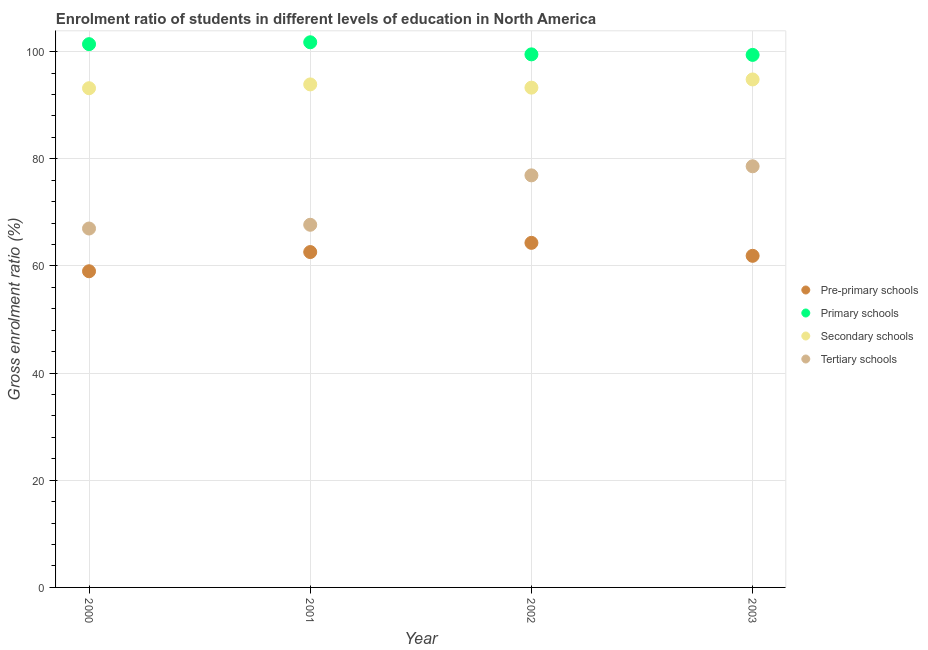How many different coloured dotlines are there?
Provide a succinct answer. 4. Is the number of dotlines equal to the number of legend labels?
Offer a terse response. Yes. What is the gross enrolment ratio in pre-primary schools in 2000?
Offer a terse response. 59.01. Across all years, what is the maximum gross enrolment ratio in primary schools?
Offer a very short reply. 101.74. Across all years, what is the minimum gross enrolment ratio in secondary schools?
Give a very brief answer. 93.17. What is the total gross enrolment ratio in pre-primary schools in the graph?
Keep it short and to the point. 247.8. What is the difference between the gross enrolment ratio in pre-primary schools in 2000 and that in 2003?
Keep it short and to the point. -2.88. What is the difference between the gross enrolment ratio in tertiary schools in 2003 and the gross enrolment ratio in secondary schools in 2002?
Keep it short and to the point. -14.68. What is the average gross enrolment ratio in tertiary schools per year?
Provide a short and direct response. 72.54. In the year 2001, what is the difference between the gross enrolment ratio in pre-primary schools and gross enrolment ratio in primary schools?
Keep it short and to the point. -39.15. In how many years, is the gross enrolment ratio in pre-primary schools greater than 92 %?
Your response must be concise. 0. What is the ratio of the gross enrolment ratio in primary schools in 2000 to that in 2001?
Give a very brief answer. 1. Is the gross enrolment ratio in secondary schools in 2001 less than that in 2003?
Give a very brief answer. Yes. Is the difference between the gross enrolment ratio in pre-primary schools in 2000 and 2003 greater than the difference between the gross enrolment ratio in secondary schools in 2000 and 2003?
Offer a very short reply. No. What is the difference between the highest and the second highest gross enrolment ratio in tertiary schools?
Keep it short and to the point. 1.69. What is the difference between the highest and the lowest gross enrolment ratio in tertiary schools?
Your answer should be compact. 11.61. Is the sum of the gross enrolment ratio in primary schools in 2000 and 2003 greater than the maximum gross enrolment ratio in secondary schools across all years?
Provide a succinct answer. Yes. Is it the case that in every year, the sum of the gross enrolment ratio in secondary schools and gross enrolment ratio in tertiary schools is greater than the sum of gross enrolment ratio in pre-primary schools and gross enrolment ratio in primary schools?
Your answer should be very brief. No. Is it the case that in every year, the sum of the gross enrolment ratio in pre-primary schools and gross enrolment ratio in primary schools is greater than the gross enrolment ratio in secondary schools?
Keep it short and to the point. Yes. Is the gross enrolment ratio in pre-primary schools strictly less than the gross enrolment ratio in secondary schools over the years?
Give a very brief answer. Yes. How many dotlines are there?
Give a very brief answer. 4. How many years are there in the graph?
Your answer should be compact. 4. What is the difference between two consecutive major ticks on the Y-axis?
Provide a succinct answer. 20. Are the values on the major ticks of Y-axis written in scientific E-notation?
Offer a very short reply. No. Does the graph contain any zero values?
Provide a short and direct response. No. Where does the legend appear in the graph?
Keep it short and to the point. Center right. How are the legend labels stacked?
Ensure brevity in your answer.  Vertical. What is the title of the graph?
Provide a short and direct response. Enrolment ratio of students in different levels of education in North America. Does "Quality of logistic services" appear as one of the legend labels in the graph?
Offer a very short reply. No. What is the label or title of the Y-axis?
Keep it short and to the point. Gross enrolment ratio (%). What is the Gross enrolment ratio (%) in Pre-primary schools in 2000?
Your response must be concise. 59.01. What is the Gross enrolment ratio (%) of Primary schools in 2000?
Make the answer very short. 101.39. What is the Gross enrolment ratio (%) in Secondary schools in 2000?
Ensure brevity in your answer.  93.17. What is the Gross enrolment ratio (%) in Tertiary schools in 2000?
Your response must be concise. 66.98. What is the Gross enrolment ratio (%) in Pre-primary schools in 2001?
Offer a terse response. 62.59. What is the Gross enrolment ratio (%) of Primary schools in 2001?
Make the answer very short. 101.74. What is the Gross enrolment ratio (%) in Secondary schools in 2001?
Ensure brevity in your answer.  93.88. What is the Gross enrolment ratio (%) of Tertiary schools in 2001?
Make the answer very short. 67.68. What is the Gross enrolment ratio (%) in Pre-primary schools in 2002?
Keep it short and to the point. 64.31. What is the Gross enrolment ratio (%) of Primary schools in 2002?
Your response must be concise. 99.49. What is the Gross enrolment ratio (%) of Secondary schools in 2002?
Keep it short and to the point. 93.28. What is the Gross enrolment ratio (%) of Tertiary schools in 2002?
Give a very brief answer. 76.91. What is the Gross enrolment ratio (%) in Pre-primary schools in 2003?
Keep it short and to the point. 61.89. What is the Gross enrolment ratio (%) of Primary schools in 2003?
Provide a short and direct response. 99.39. What is the Gross enrolment ratio (%) in Secondary schools in 2003?
Your answer should be very brief. 94.81. What is the Gross enrolment ratio (%) in Tertiary schools in 2003?
Your answer should be very brief. 78.6. Across all years, what is the maximum Gross enrolment ratio (%) of Pre-primary schools?
Make the answer very short. 64.31. Across all years, what is the maximum Gross enrolment ratio (%) in Primary schools?
Keep it short and to the point. 101.74. Across all years, what is the maximum Gross enrolment ratio (%) in Secondary schools?
Your answer should be very brief. 94.81. Across all years, what is the maximum Gross enrolment ratio (%) of Tertiary schools?
Keep it short and to the point. 78.6. Across all years, what is the minimum Gross enrolment ratio (%) of Pre-primary schools?
Ensure brevity in your answer.  59.01. Across all years, what is the minimum Gross enrolment ratio (%) of Primary schools?
Keep it short and to the point. 99.39. Across all years, what is the minimum Gross enrolment ratio (%) of Secondary schools?
Keep it short and to the point. 93.17. Across all years, what is the minimum Gross enrolment ratio (%) in Tertiary schools?
Your answer should be very brief. 66.98. What is the total Gross enrolment ratio (%) of Pre-primary schools in the graph?
Make the answer very short. 247.8. What is the total Gross enrolment ratio (%) in Primary schools in the graph?
Keep it short and to the point. 402.01. What is the total Gross enrolment ratio (%) of Secondary schools in the graph?
Ensure brevity in your answer.  375.13. What is the total Gross enrolment ratio (%) of Tertiary schools in the graph?
Keep it short and to the point. 290.17. What is the difference between the Gross enrolment ratio (%) of Pre-primary schools in 2000 and that in 2001?
Provide a short and direct response. -3.58. What is the difference between the Gross enrolment ratio (%) of Primary schools in 2000 and that in 2001?
Your response must be concise. -0.35. What is the difference between the Gross enrolment ratio (%) in Secondary schools in 2000 and that in 2001?
Give a very brief answer. -0.71. What is the difference between the Gross enrolment ratio (%) of Pre-primary schools in 2000 and that in 2002?
Offer a terse response. -5.3. What is the difference between the Gross enrolment ratio (%) in Primary schools in 2000 and that in 2002?
Keep it short and to the point. 1.9. What is the difference between the Gross enrolment ratio (%) in Secondary schools in 2000 and that in 2002?
Your answer should be compact. -0.11. What is the difference between the Gross enrolment ratio (%) in Tertiary schools in 2000 and that in 2002?
Provide a succinct answer. -9.92. What is the difference between the Gross enrolment ratio (%) in Pre-primary schools in 2000 and that in 2003?
Your answer should be compact. -2.88. What is the difference between the Gross enrolment ratio (%) in Primary schools in 2000 and that in 2003?
Keep it short and to the point. 2. What is the difference between the Gross enrolment ratio (%) in Secondary schools in 2000 and that in 2003?
Your response must be concise. -1.64. What is the difference between the Gross enrolment ratio (%) of Tertiary schools in 2000 and that in 2003?
Your answer should be very brief. -11.61. What is the difference between the Gross enrolment ratio (%) of Pre-primary schools in 2001 and that in 2002?
Provide a short and direct response. -1.72. What is the difference between the Gross enrolment ratio (%) of Primary schools in 2001 and that in 2002?
Keep it short and to the point. 2.26. What is the difference between the Gross enrolment ratio (%) in Secondary schools in 2001 and that in 2002?
Give a very brief answer. 0.6. What is the difference between the Gross enrolment ratio (%) of Tertiary schools in 2001 and that in 2002?
Provide a succinct answer. -9.22. What is the difference between the Gross enrolment ratio (%) of Pre-primary schools in 2001 and that in 2003?
Offer a terse response. 0.7. What is the difference between the Gross enrolment ratio (%) in Primary schools in 2001 and that in 2003?
Keep it short and to the point. 2.36. What is the difference between the Gross enrolment ratio (%) of Secondary schools in 2001 and that in 2003?
Ensure brevity in your answer.  -0.93. What is the difference between the Gross enrolment ratio (%) in Tertiary schools in 2001 and that in 2003?
Keep it short and to the point. -10.91. What is the difference between the Gross enrolment ratio (%) in Pre-primary schools in 2002 and that in 2003?
Offer a terse response. 2.42. What is the difference between the Gross enrolment ratio (%) in Primary schools in 2002 and that in 2003?
Give a very brief answer. 0.1. What is the difference between the Gross enrolment ratio (%) in Secondary schools in 2002 and that in 2003?
Your answer should be compact. -1.53. What is the difference between the Gross enrolment ratio (%) in Tertiary schools in 2002 and that in 2003?
Your answer should be very brief. -1.69. What is the difference between the Gross enrolment ratio (%) of Pre-primary schools in 2000 and the Gross enrolment ratio (%) of Primary schools in 2001?
Ensure brevity in your answer.  -42.74. What is the difference between the Gross enrolment ratio (%) in Pre-primary schools in 2000 and the Gross enrolment ratio (%) in Secondary schools in 2001?
Provide a succinct answer. -34.87. What is the difference between the Gross enrolment ratio (%) of Pre-primary schools in 2000 and the Gross enrolment ratio (%) of Tertiary schools in 2001?
Offer a very short reply. -8.68. What is the difference between the Gross enrolment ratio (%) of Primary schools in 2000 and the Gross enrolment ratio (%) of Secondary schools in 2001?
Your response must be concise. 7.51. What is the difference between the Gross enrolment ratio (%) of Primary schools in 2000 and the Gross enrolment ratio (%) of Tertiary schools in 2001?
Make the answer very short. 33.71. What is the difference between the Gross enrolment ratio (%) in Secondary schools in 2000 and the Gross enrolment ratio (%) in Tertiary schools in 2001?
Your response must be concise. 25.48. What is the difference between the Gross enrolment ratio (%) of Pre-primary schools in 2000 and the Gross enrolment ratio (%) of Primary schools in 2002?
Provide a short and direct response. -40.48. What is the difference between the Gross enrolment ratio (%) of Pre-primary schools in 2000 and the Gross enrolment ratio (%) of Secondary schools in 2002?
Keep it short and to the point. -34.27. What is the difference between the Gross enrolment ratio (%) in Pre-primary schools in 2000 and the Gross enrolment ratio (%) in Tertiary schools in 2002?
Your answer should be compact. -17.9. What is the difference between the Gross enrolment ratio (%) in Primary schools in 2000 and the Gross enrolment ratio (%) in Secondary schools in 2002?
Provide a succinct answer. 8.12. What is the difference between the Gross enrolment ratio (%) of Primary schools in 2000 and the Gross enrolment ratio (%) of Tertiary schools in 2002?
Your answer should be very brief. 24.49. What is the difference between the Gross enrolment ratio (%) of Secondary schools in 2000 and the Gross enrolment ratio (%) of Tertiary schools in 2002?
Provide a short and direct response. 16.26. What is the difference between the Gross enrolment ratio (%) of Pre-primary schools in 2000 and the Gross enrolment ratio (%) of Primary schools in 2003?
Make the answer very short. -40.38. What is the difference between the Gross enrolment ratio (%) in Pre-primary schools in 2000 and the Gross enrolment ratio (%) in Secondary schools in 2003?
Ensure brevity in your answer.  -35.8. What is the difference between the Gross enrolment ratio (%) of Pre-primary schools in 2000 and the Gross enrolment ratio (%) of Tertiary schools in 2003?
Make the answer very short. -19.59. What is the difference between the Gross enrolment ratio (%) of Primary schools in 2000 and the Gross enrolment ratio (%) of Secondary schools in 2003?
Your response must be concise. 6.59. What is the difference between the Gross enrolment ratio (%) in Primary schools in 2000 and the Gross enrolment ratio (%) in Tertiary schools in 2003?
Give a very brief answer. 22.79. What is the difference between the Gross enrolment ratio (%) of Secondary schools in 2000 and the Gross enrolment ratio (%) of Tertiary schools in 2003?
Make the answer very short. 14.57. What is the difference between the Gross enrolment ratio (%) of Pre-primary schools in 2001 and the Gross enrolment ratio (%) of Primary schools in 2002?
Your answer should be very brief. -36.9. What is the difference between the Gross enrolment ratio (%) in Pre-primary schools in 2001 and the Gross enrolment ratio (%) in Secondary schools in 2002?
Provide a short and direct response. -30.68. What is the difference between the Gross enrolment ratio (%) of Pre-primary schools in 2001 and the Gross enrolment ratio (%) of Tertiary schools in 2002?
Make the answer very short. -14.31. What is the difference between the Gross enrolment ratio (%) in Primary schools in 2001 and the Gross enrolment ratio (%) in Secondary schools in 2002?
Make the answer very short. 8.47. What is the difference between the Gross enrolment ratio (%) of Primary schools in 2001 and the Gross enrolment ratio (%) of Tertiary schools in 2002?
Offer a terse response. 24.84. What is the difference between the Gross enrolment ratio (%) in Secondary schools in 2001 and the Gross enrolment ratio (%) in Tertiary schools in 2002?
Provide a short and direct response. 16.98. What is the difference between the Gross enrolment ratio (%) in Pre-primary schools in 2001 and the Gross enrolment ratio (%) in Primary schools in 2003?
Offer a terse response. -36.8. What is the difference between the Gross enrolment ratio (%) in Pre-primary schools in 2001 and the Gross enrolment ratio (%) in Secondary schools in 2003?
Ensure brevity in your answer.  -32.21. What is the difference between the Gross enrolment ratio (%) in Pre-primary schools in 2001 and the Gross enrolment ratio (%) in Tertiary schools in 2003?
Your answer should be compact. -16.01. What is the difference between the Gross enrolment ratio (%) of Primary schools in 2001 and the Gross enrolment ratio (%) of Secondary schools in 2003?
Offer a terse response. 6.94. What is the difference between the Gross enrolment ratio (%) in Primary schools in 2001 and the Gross enrolment ratio (%) in Tertiary schools in 2003?
Provide a short and direct response. 23.14. What is the difference between the Gross enrolment ratio (%) of Secondary schools in 2001 and the Gross enrolment ratio (%) of Tertiary schools in 2003?
Offer a terse response. 15.28. What is the difference between the Gross enrolment ratio (%) of Pre-primary schools in 2002 and the Gross enrolment ratio (%) of Primary schools in 2003?
Provide a short and direct response. -35.08. What is the difference between the Gross enrolment ratio (%) in Pre-primary schools in 2002 and the Gross enrolment ratio (%) in Secondary schools in 2003?
Make the answer very short. -30.5. What is the difference between the Gross enrolment ratio (%) of Pre-primary schools in 2002 and the Gross enrolment ratio (%) of Tertiary schools in 2003?
Provide a succinct answer. -14.29. What is the difference between the Gross enrolment ratio (%) in Primary schools in 2002 and the Gross enrolment ratio (%) in Secondary schools in 2003?
Offer a terse response. 4.68. What is the difference between the Gross enrolment ratio (%) in Primary schools in 2002 and the Gross enrolment ratio (%) in Tertiary schools in 2003?
Provide a short and direct response. 20.89. What is the difference between the Gross enrolment ratio (%) of Secondary schools in 2002 and the Gross enrolment ratio (%) of Tertiary schools in 2003?
Provide a succinct answer. 14.68. What is the average Gross enrolment ratio (%) of Pre-primary schools per year?
Give a very brief answer. 61.95. What is the average Gross enrolment ratio (%) of Primary schools per year?
Provide a succinct answer. 100.5. What is the average Gross enrolment ratio (%) of Secondary schools per year?
Ensure brevity in your answer.  93.78. What is the average Gross enrolment ratio (%) of Tertiary schools per year?
Give a very brief answer. 72.54. In the year 2000, what is the difference between the Gross enrolment ratio (%) in Pre-primary schools and Gross enrolment ratio (%) in Primary schools?
Your answer should be very brief. -42.38. In the year 2000, what is the difference between the Gross enrolment ratio (%) of Pre-primary schools and Gross enrolment ratio (%) of Secondary schools?
Offer a terse response. -34.16. In the year 2000, what is the difference between the Gross enrolment ratio (%) in Pre-primary schools and Gross enrolment ratio (%) in Tertiary schools?
Your response must be concise. -7.98. In the year 2000, what is the difference between the Gross enrolment ratio (%) of Primary schools and Gross enrolment ratio (%) of Secondary schools?
Your response must be concise. 8.22. In the year 2000, what is the difference between the Gross enrolment ratio (%) of Primary schools and Gross enrolment ratio (%) of Tertiary schools?
Give a very brief answer. 34.41. In the year 2000, what is the difference between the Gross enrolment ratio (%) of Secondary schools and Gross enrolment ratio (%) of Tertiary schools?
Keep it short and to the point. 26.18. In the year 2001, what is the difference between the Gross enrolment ratio (%) of Pre-primary schools and Gross enrolment ratio (%) of Primary schools?
Your answer should be compact. -39.15. In the year 2001, what is the difference between the Gross enrolment ratio (%) of Pre-primary schools and Gross enrolment ratio (%) of Secondary schools?
Your response must be concise. -31.29. In the year 2001, what is the difference between the Gross enrolment ratio (%) of Pre-primary schools and Gross enrolment ratio (%) of Tertiary schools?
Your answer should be compact. -5.09. In the year 2001, what is the difference between the Gross enrolment ratio (%) in Primary schools and Gross enrolment ratio (%) in Secondary schools?
Your answer should be compact. 7.86. In the year 2001, what is the difference between the Gross enrolment ratio (%) of Primary schools and Gross enrolment ratio (%) of Tertiary schools?
Provide a short and direct response. 34.06. In the year 2001, what is the difference between the Gross enrolment ratio (%) of Secondary schools and Gross enrolment ratio (%) of Tertiary schools?
Make the answer very short. 26.2. In the year 2002, what is the difference between the Gross enrolment ratio (%) of Pre-primary schools and Gross enrolment ratio (%) of Primary schools?
Offer a very short reply. -35.18. In the year 2002, what is the difference between the Gross enrolment ratio (%) of Pre-primary schools and Gross enrolment ratio (%) of Secondary schools?
Keep it short and to the point. -28.97. In the year 2002, what is the difference between the Gross enrolment ratio (%) in Pre-primary schools and Gross enrolment ratio (%) in Tertiary schools?
Offer a very short reply. -12.6. In the year 2002, what is the difference between the Gross enrolment ratio (%) in Primary schools and Gross enrolment ratio (%) in Secondary schools?
Make the answer very short. 6.21. In the year 2002, what is the difference between the Gross enrolment ratio (%) of Primary schools and Gross enrolment ratio (%) of Tertiary schools?
Offer a terse response. 22.58. In the year 2002, what is the difference between the Gross enrolment ratio (%) of Secondary schools and Gross enrolment ratio (%) of Tertiary schools?
Keep it short and to the point. 16.37. In the year 2003, what is the difference between the Gross enrolment ratio (%) of Pre-primary schools and Gross enrolment ratio (%) of Primary schools?
Offer a very short reply. -37.5. In the year 2003, what is the difference between the Gross enrolment ratio (%) in Pre-primary schools and Gross enrolment ratio (%) in Secondary schools?
Make the answer very short. -32.92. In the year 2003, what is the difference between the Gross enrolment ratio (%) of Pre-primary schools and Gross enrolment ratio (%) of Tertiary schools?
Your answer should be compact. -16.71. In the year 2003, what is the difference between the Gross enrolment ratio (%) of Primary schools and Gross enrolment ratio (%) of Secondary schools?
Offer a very short reply. 4.58. In the year 2003, what is the difference between the Gross enrolment ratio (%) in Primary schools and Gross enrolment ratio (%) in Tertiary schools?
Keep it short and to the point. 20.79. In the year 2003, what is the difference between the Gross enrolment ratio (%) of Secondary schools and Gross enrolment ratio (%) of Tertiary schools?
Provide a succinct answer. 16.21. What is the ratio of the Gross enrolment ratio (%) in Pre-primary schools in 2000 to that in 2001?
Provide a short and direct response. 0.94. What is the ratio of the Gross enrolment ratio (%) of Primary schools in 2000 to that in 2001?
Make the answer very short. 1. What is the ratio of the Gross enrolment ratio (%) in Secondary schools in 2000 to that in 2001?
Keep it short and to the point. 0.99. What is the ratio of the Gross enrolment ratio (%) of Pre-primary schools in 2000 to that in 2002?
Your answer should be compact. 0.92. What is the ratio of the Gross enrolment ratio (%) of Primary schools in 2000 to that in 2002?
Offer a terse response. 1.02. What is the ratio of the Gross enrolment ratio (%) in Tertiary schools in 2000 to that in 2002?
Provide a succinct answer. 0.87. What is the ratio of the Gross enrolment ratio (%) of Pre-primary schools in 2000 to that in 2003?
Keep it short and to the point. 0.95. What is the ratio of the Gross enrolment ratio (%) in Primary schools in 2000 to that in 2003?
Keep it short and to the point. 1.02. What is the ratio of the Gross enrolment ratio (%) in Secondary schools in 2000 to that in 2003?
Provide a short and direct response. 0.98. What is the ratio of the Gross enrolment ratio (%) in Tertiary schools in 2000 to that in 2003?
Give a very brief answer. 0.85. What is the ratio of the Gross enrolment ratio (%) of Pre-primary schools in 2001 to that in 2002?
Offer a terse response. 0.97. What is the ratio of the Gross enrolment ratio (%) of Primary schools in 2001 to that in 2002?
Give a very brief answer. 1.02. What is the ratio of the Gross enrolment ratio (%) in Tertiary schools in 2001 to that in 2002?
Make the answer very short. 0.88. What is the ratio of the Gross enrolment ratio (%) of Pre-primary schools in 2001 to that in 2003?
Your answer should be compact. 1.01. What is the ratio of the Gross enrolment ratio (%) in Primary schools in 2001 to that in 2003?
Ensure brevity in your answer.  1.02. What is the ratio of the Gross enrolment ratio (%) of Secondary schools in 2001 to that in 2003?
Offer a terse response. 0.99. What is the ratio of the Gross enrolment ratio (%) of Tertiary schools in 2001 to that in 2003?
Provide a short and direct response. 0.86. What is the ratio of the Gross enrolment ratio (%) of Pre-primary schools in 2002 to that in 2003?
Offer a very short reply. 1.04. What is the ratio of the Gross enrolment ratio (%) of Primary schools in 2002 to that in 2003?
Your answer should be very brief. 1. What is the ratio of the Gross enrolment ratio (%) in Secondary schools in 2002 to that in 2003?
Your answer should be very brief. 0.98. What is the ratio of the Gross enrolment ratio (%) of Tertiary schools in 2002 to that in 2003?
Give a very brief answer. 0.98. What is the difference between the highest and the second highest Gross enrolment ratio (%) in Pre-primary schools?
Keep it short and to the point. 1.72. What is the difference between the highest and the second highest Gross enrolment ratio (%) in Primary schools?
Keep it short and to the point. 0.35. What is the difference between the highest and the second highest Gross enrolment ratio (%) of Secondary schools?
Keep it short and to the point. 0.93. What is the difference between the highest and the second highest Gross enrolment ratio (%) in Tertiary schools?
Provide a short and direct response. 1.69. What is the difference between the highest and the lowest Gross enrolment ratio (%) of Pre-primary schools?
Offer a very short reply. 5.3. What is the difference between the highest and the lowest Gross enrolment ratio (%) in Primary schools?
Provide a succinct answer. 2.36. What is the difference between the highest and the lowest Gross enrolment ratio (%) of Secondary schools?
Offer a terse response. 1.64. What is the difference between the highest and the lowest Gross enrolment ratio (%) of Tertiary schools?
Make the answer very short. 11.61. 